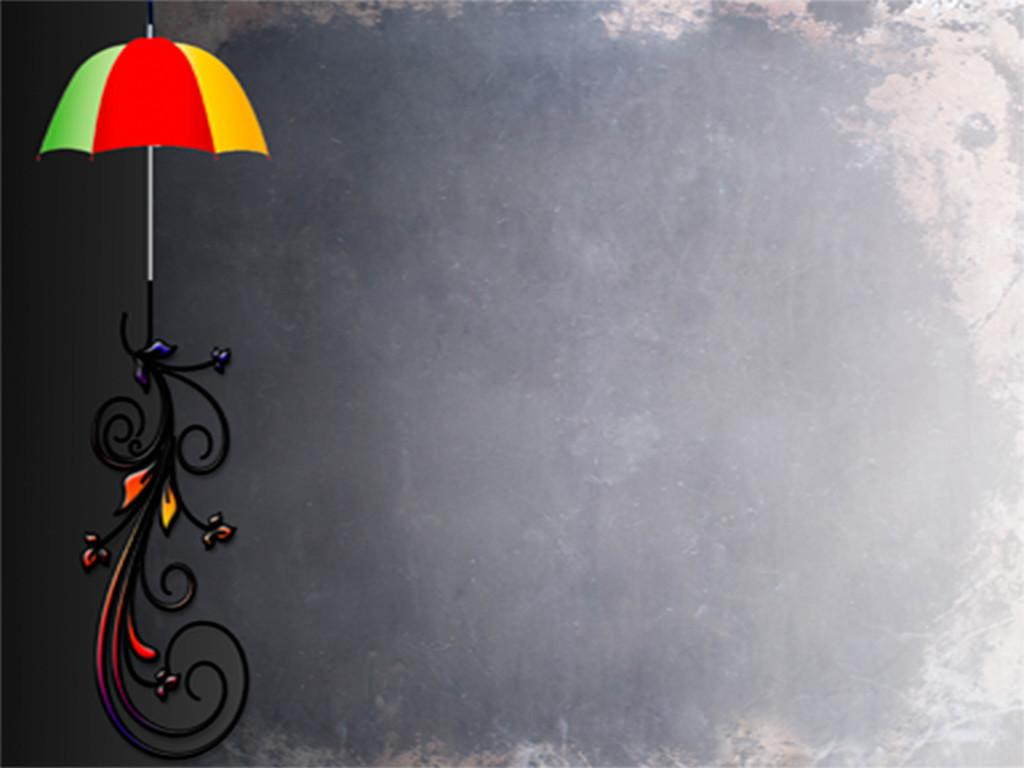What object can be seen in the image? There is an umbrella in the image. What is the umbrella placed on? The umbrella is on a design. What color is the background of the image? The background of the image is black. What type of jeans is the person wearing in the image? There is no person or jeans present in the image; it only features an umbrella on a design with a black background. 